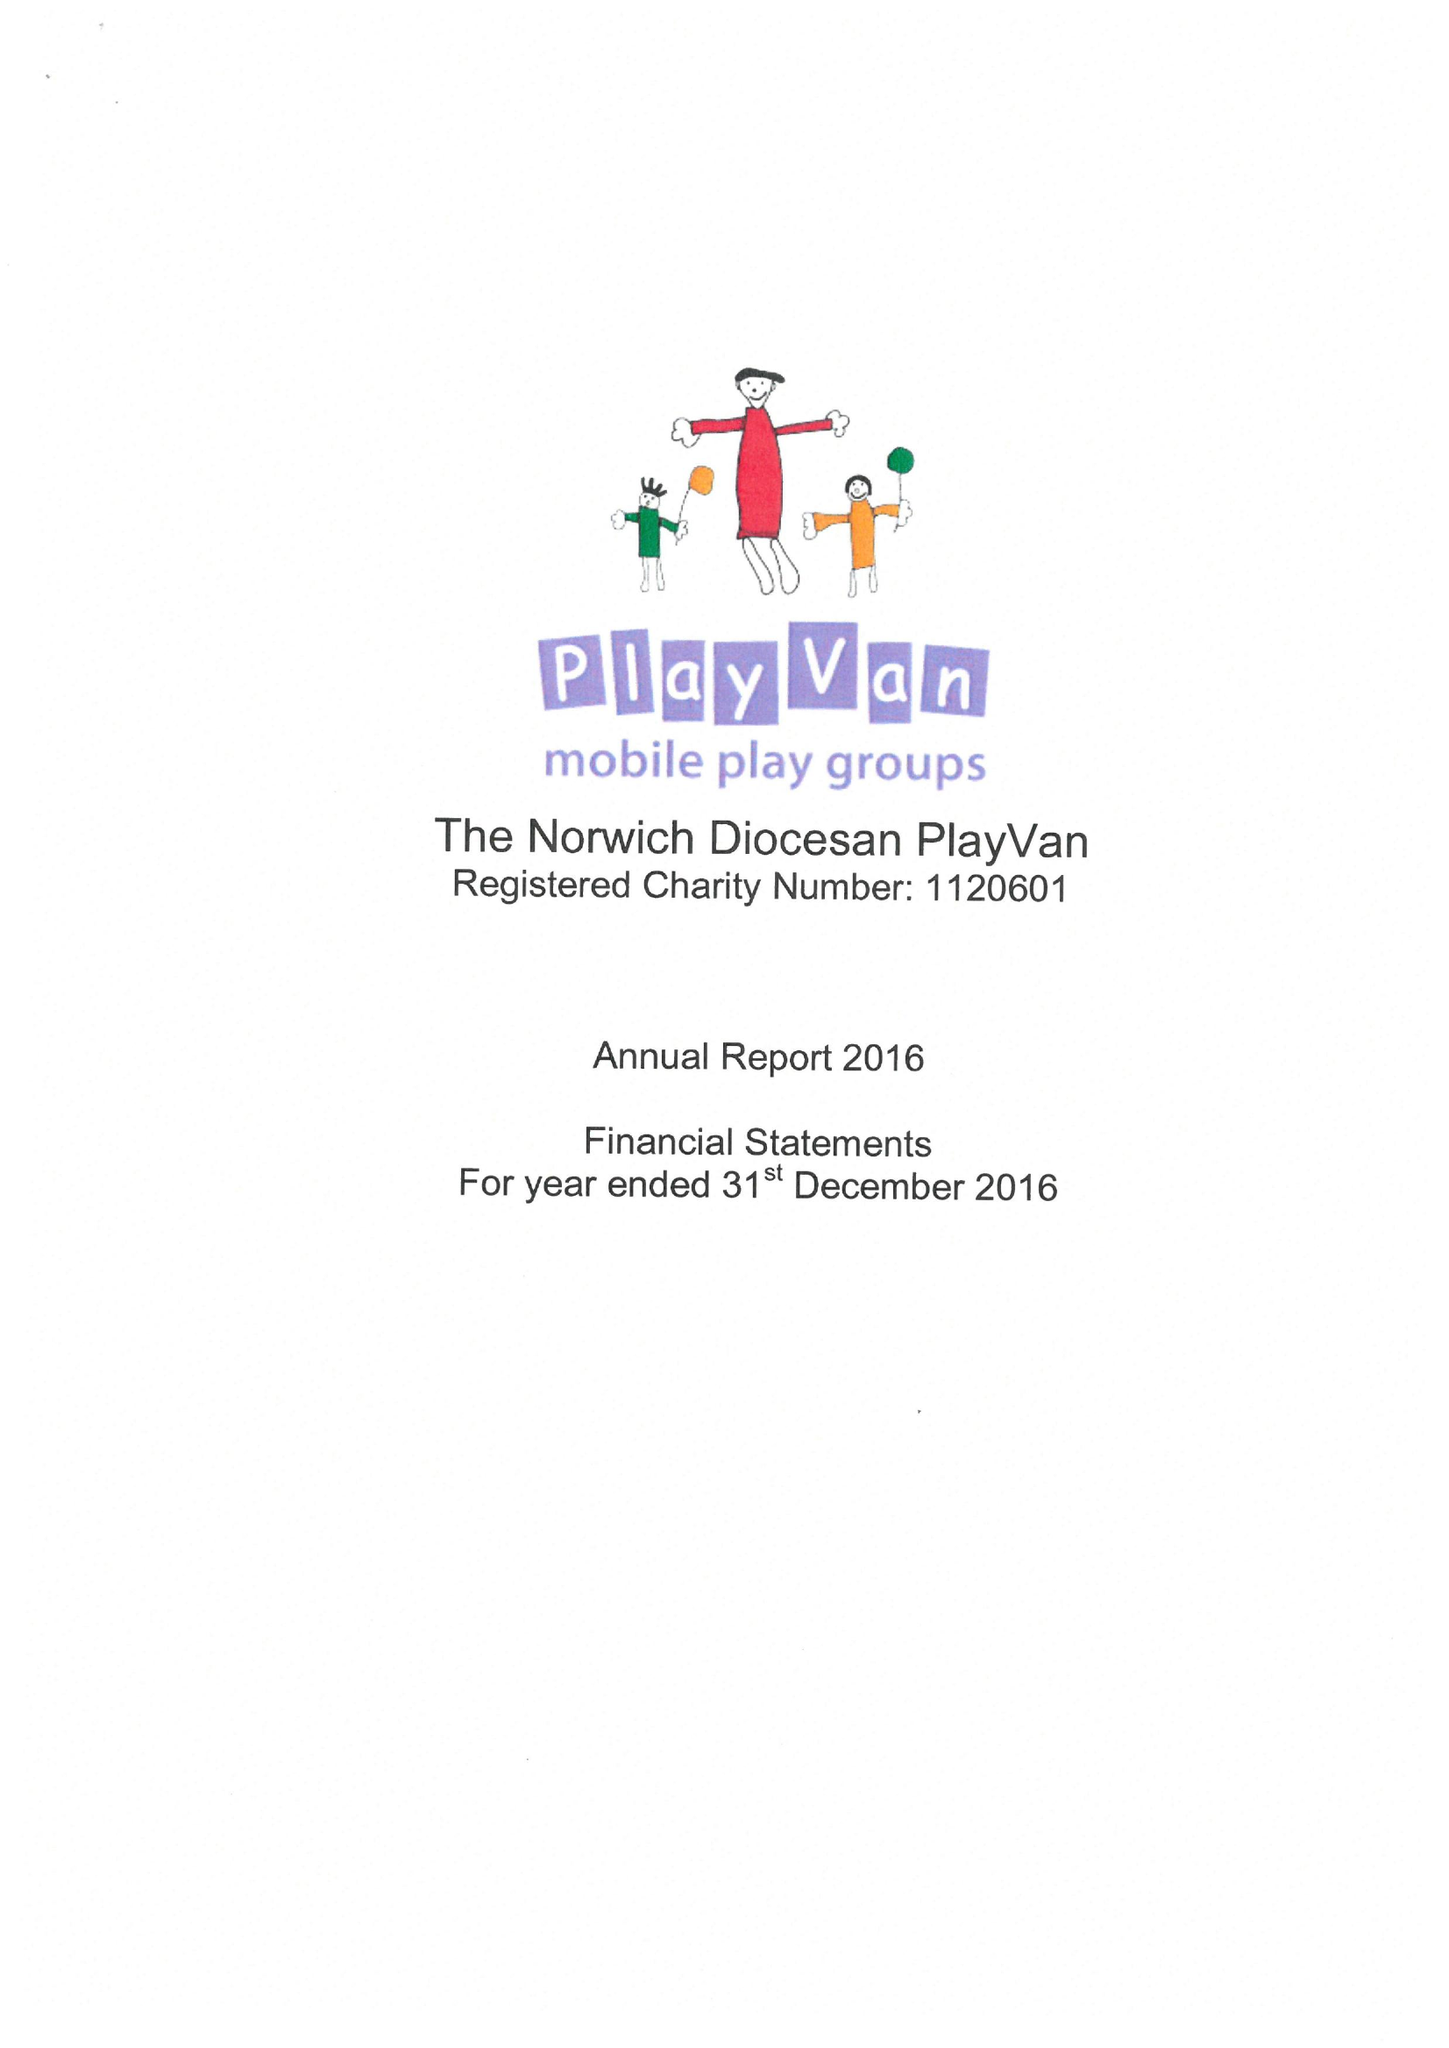What is the value for the address__post_town?
Answer the question using a single word or phrase. NORWICH 